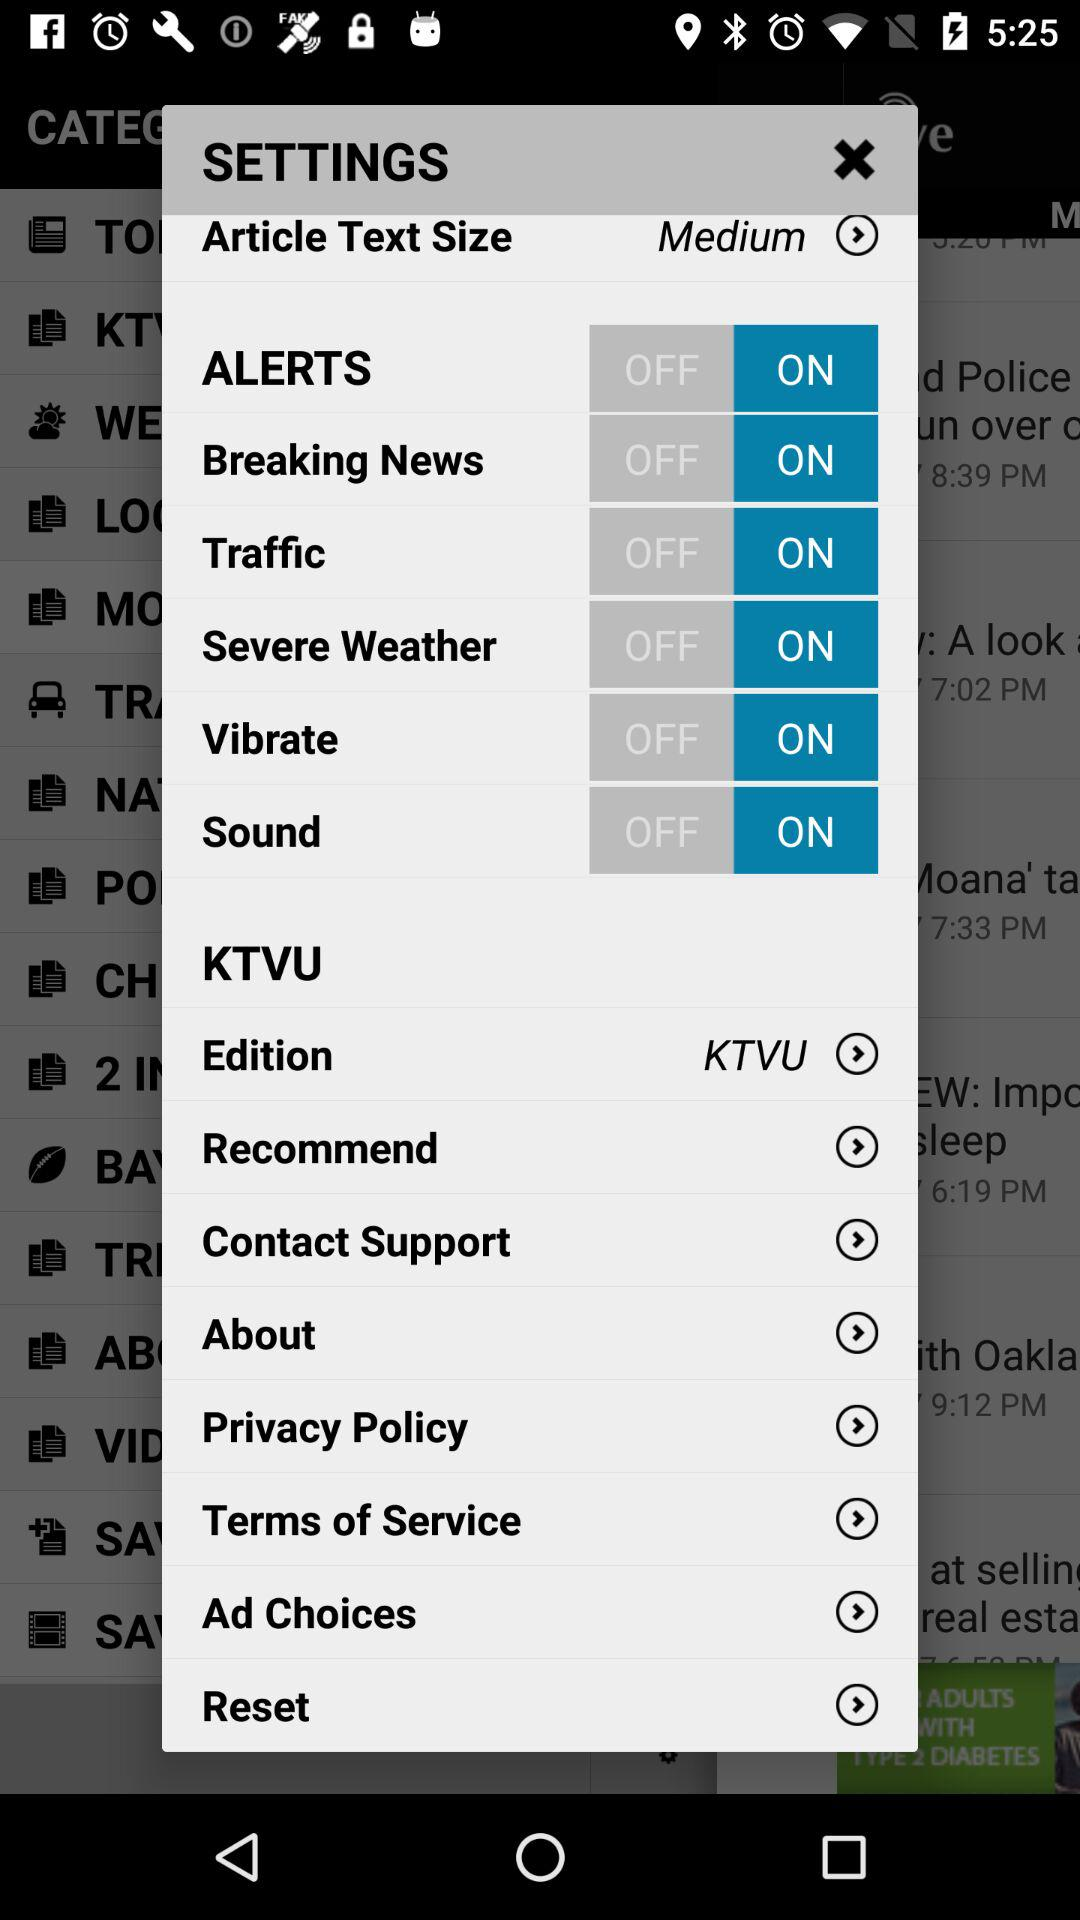What is the selected article text size? The selected article text size is medium. 